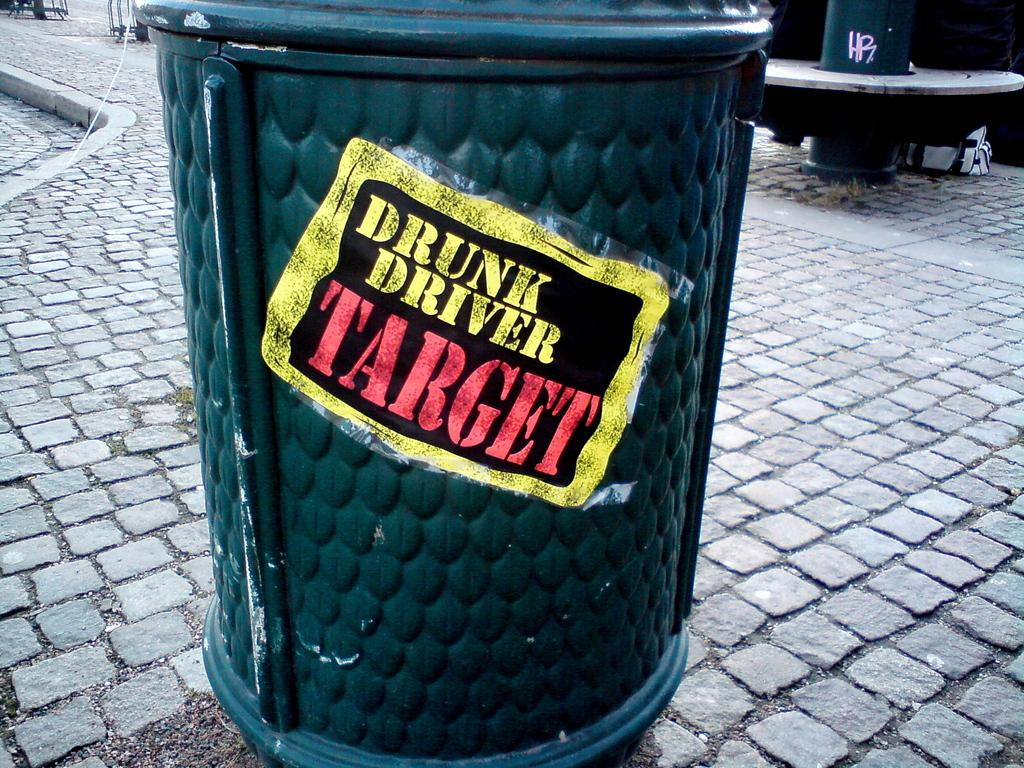<image>
Describe the image concisely. The outdoor trash bin has a sign that says, 'drunk driver target'. 